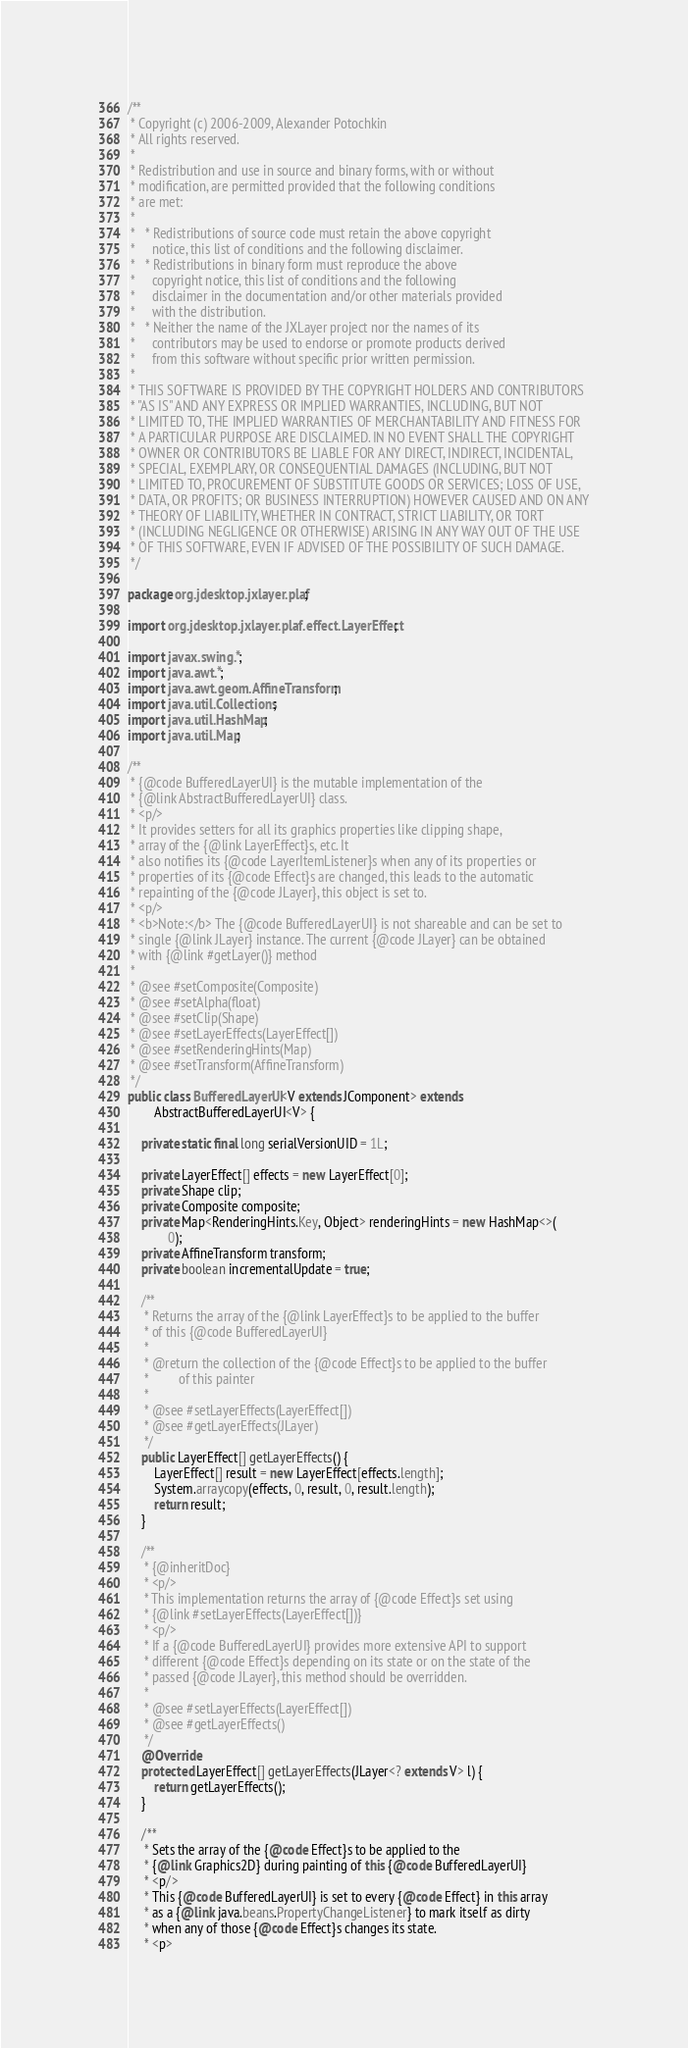<code> <loc_0><loc_0><loc_500><loc_500><_Java_>/**
 * Copyright (c) 2006-2009, Alexander Potochkin
 * All rights reserved.
 *
 * Redistribution and use in source and binary forms, with or without
 * modification, are permitted provided that the following conditions
 * are met:
 *
 *   * Redistributions of source code must retain the above copyright
 *     notice, this list of conditions and the following disclaimer.
 *   * Redistributions in binary form must reproduce the above
 *     copyright notice, this list of conditions and the following
 *     disclaimer in the documentation and/or other materials provided
 *     with the distribution.
 *   * Neither the name of the JXLayer project nor the names of its
 *     contributors may be used to endorse or promote products derived
 *     from this software without specific prior written permission.
 *
 * THIS SOFTWARE IS PROVIDED BY THE COPYRIGHT HOLDERS AND CONTRIBUTORS
 * "AS IS" AND ANY EXPRESS OR IMPLIED WARRANTIES, INCLUDING, BUT NOT
 * LIMITED TO, THE IMPLIED WARRANTIES OF MERCHANTABILITY AND FITNESS FOR
 * A PARTICULAR PURPOSE ARE DISCLAIMED. IN NO EVENT SHALL THE COPYRIGHT
 * OWNER OR CONTRIBUTORS BE LIABLE FOR ANY DIRECT, INDIRECT, INCIDENTAL,
 * SPECIAL, EXEMPLARY, OR CONSEQUENTIAL DAMAGES (INCLUDING, BUT NOT
 * LIMITED TO, PROCUREMENT OF SUBSTITUTE GOODS OR SERVICES; LOSS OF USE,
 * DATA, OR PROFITS; OR BUSINESS INTERRUPTION) HOWEVER CAUSED AND ON ANY
 * THEORY OF LIABILITY, WHETHER IN CONTRACT, STRICT LIABILITY, OR TORT
 * (INCLUDING NEGLIGENCE OR OTHERWISE) ARISING IN ANY WAY OUT OF THE USE
 * OF THIS SOFTWARE, EVEN IF ADVISED OF THE POSSIBILITY OF SUCH DAMAGE.
 */

package org.jdesktop.jxlayer.plaf;

import org.jdesktop.jxlayer.plaf.effect.LayerEffect;

import javax.swing.*;
import java.awt.*;
import java.awt.geom.AffineTransform;
import java.util.Collections;
import java.util.HashMap;
import java.util.Map;

/**
 * {@code BufferedLayerUI} is the mutable implementation of the
 * {@link AbstractBufferedLayerUI} class.
 * <p/>
 * It provides setters for all its graphics properties like clipping shape,
 * array of the {@link LayerEffect}s, etc. It
 * also notifies its {@code LayerItemListener}s when any of its properties or
 * properties of its {@code Effect}s are changed, this leads to the automatic
 * repainting of the {@code JLayer}, this object is set to.
 * <p/>
 * <b>Note:</b> The {@code BufferedLayerUI} is not shareable and can be set to
 * single {@link JLayer} instance. The current {@code JLayer} can be obtained
 * with {@link #getLayer()} method
 * 
 * @see #setComposite(Composite)
 * @see #setAlpha(float)
 * @see #setClip(Shape)
 * @see #setLayerEffects(LayerEffect[])
 * @see #setRenderingHints(Map)
 * @see #setTransform(AffineTransform)
 */
public class BufferedLayerUI<V extends JComponent> extends
		AbstractBufferedLayerUI<V> {

	private static final long serialVersionUID = 1L;

	private LayerEffect[] effects = new LayerEffect[0];
	private Shape clip;
	private Composite composite;
	private Map<RenderingHints.Key, Object> renderingHints = new HashMap<>(
			0);
	private AffineTransform transform;
	private boolean incrementalUpdate = true;

	/**
	 * Returns the array of the {@link LayerEffect}s to be applied to the buffer
	 * of this {@code BufferedLayerUI}
	 * 
	 * @return the collection of the {@code Effect}s to be applied to the buffer
	 *         of this painter
	 * 
	 * @see #setLayerEffects(LayerEffect[])
	 * @see #getLayerEffects(JLayer)
	 */
	public LayerEffect[] getLayerEffects() {
		LayerEffect[] result = new LayerEffect[effects.length];
		System.arraycopy(effects, 0, result, 0, result.length);
		return result;
	}

	/**
	 * {@inheritDoc}
	 * <p/>
	 * This implementation returns the array of {@code Effect}s set using
	 * {@link #setLayerEffects(LayerEffect[])}
	 * <p/>
	 * If a {@code BufferedLayerUI} provides more extensive API to support
	 * different {@code Effect}s depending on its state or on the state of the
	 * passed {@code JLayer}, this method should be overridden.
	 * 
	 * @see #setLayerEffects(LayerEffect[])
	 * @see #getLayerEffects()
	 */
	@Override
    protected LayerEffect[] getLayerEffects(JLayer<? extends V> l) {
		return getLayerEffects();
	}

	/**
	 * Sets the array of the {@code Effect}s to be applied to the
	 * {@link Graphics2D} during painting of this {@code BufferedLayerUI}
	 * <p/>
	 * This {@code BufferedLayerUI} is set to every {@code Effect} in this array
	 * as a {@link java.beans.PropertyChangeListener} to mark itself as dirty
	 * when any of those {@code Effect}s changes its state.
	 * <p></code> 